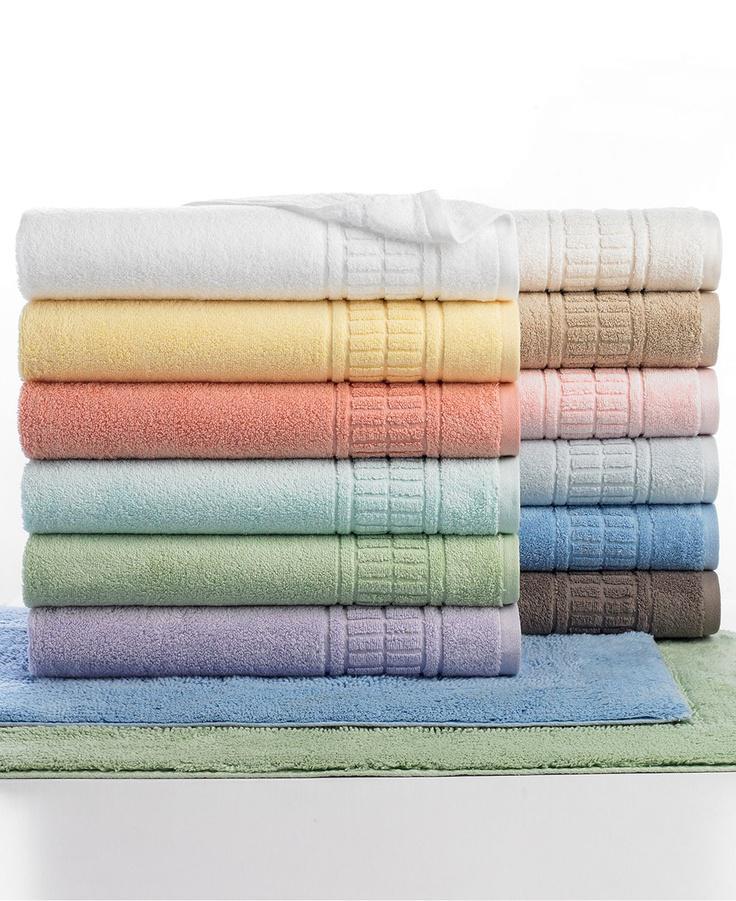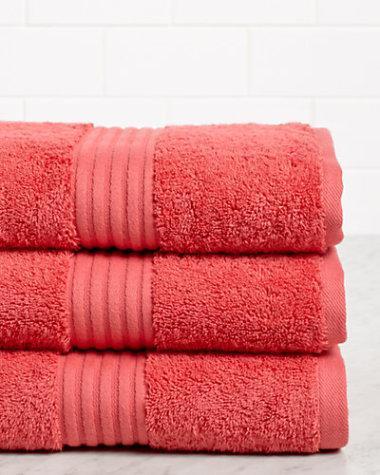The first image is the image on the left, the second image is the image on the right. Evaluate the accuracy of this statement regarding the images: "There is a stack of at least five different colored towels.". Is it true? Answer yes or no. Yes. The first image is the image on the left, the second image is the image on the right. For the images displayed, is the sentence "more than 3 stacks of colorful towels" factually correct? Answer yes or no. Yes. 